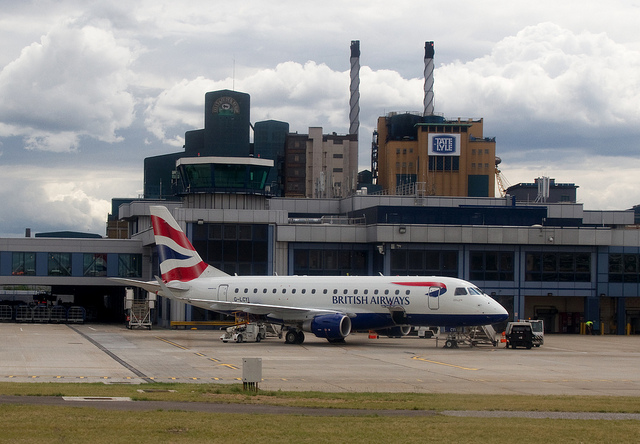How many smoke stacks are in the background? 2 